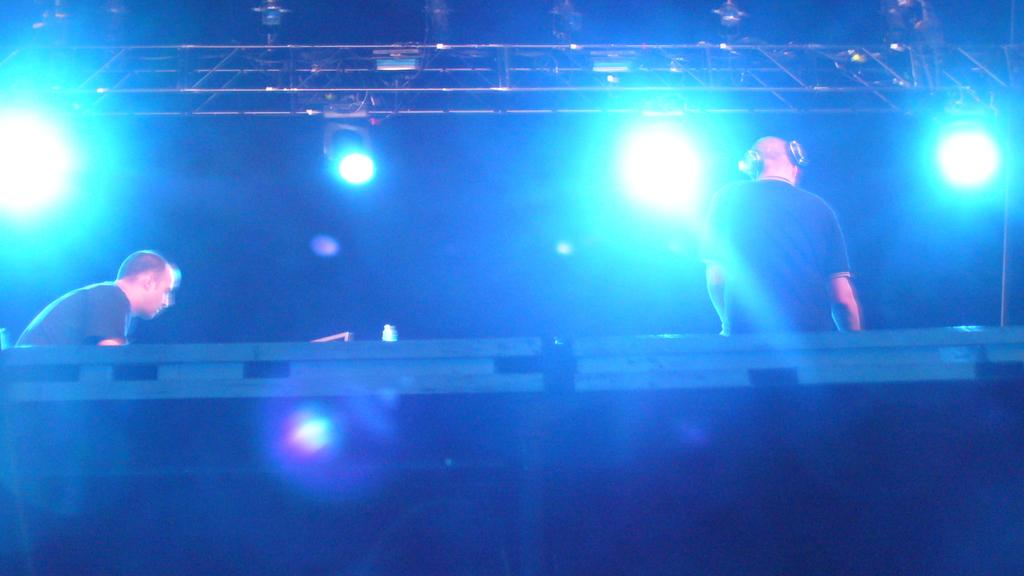How many people are in the image? There are two persons in the image. What color are the dresses worn by the persons in the image? Both persons are wearing black-colored dresses. What type of objects can be seen in the image besides the persons? There are metal rods and lights in the image. Can you describe the overall appearance of the image? The background of the image is dark. What type of hat is the person wearing in the image? There is no hat visible in the image; both persons are wearing black-colored dresses. Can you tell me how many tents are set up in the image? There are no tents present in the image. 